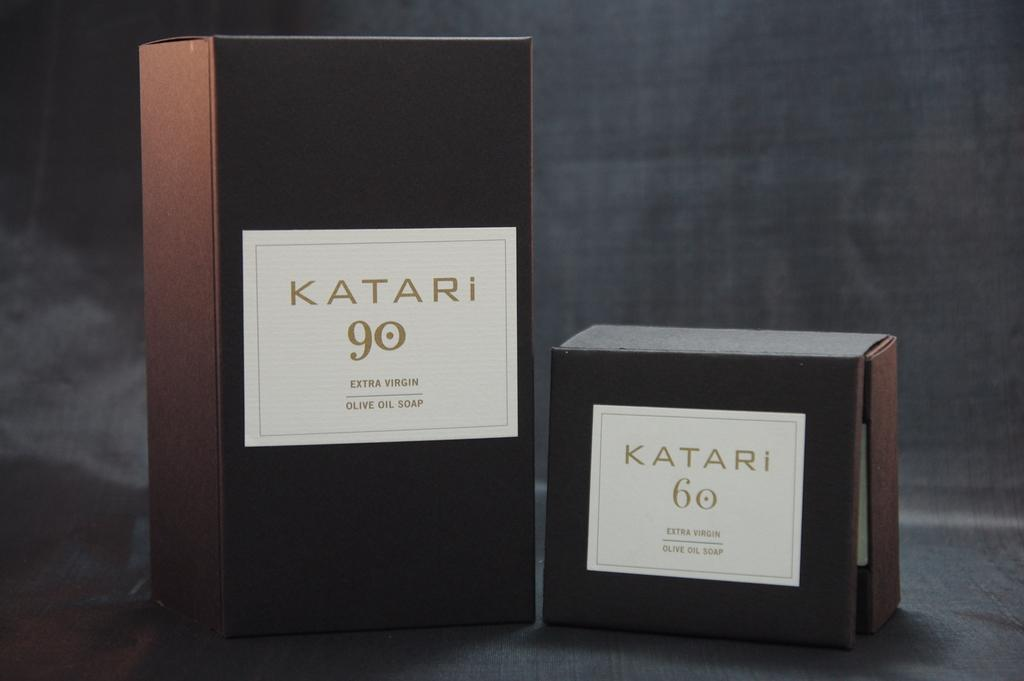<image>
Create a compact narrative representing the image presented. A small box of Katari 90 Olive Soap has been placed alongside a larger box of the same product. 